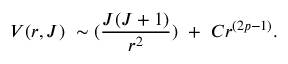Convert formula to latex. <formula><loc_0><loc_0><loc_500><loc_500>V ( r , J ) \ \sim ( { \frac { J ( J + 1 ) } { r ^ { 2 } } } ) \ + \ C r ^ { ( 2 p - 1 ) } .</formula> 